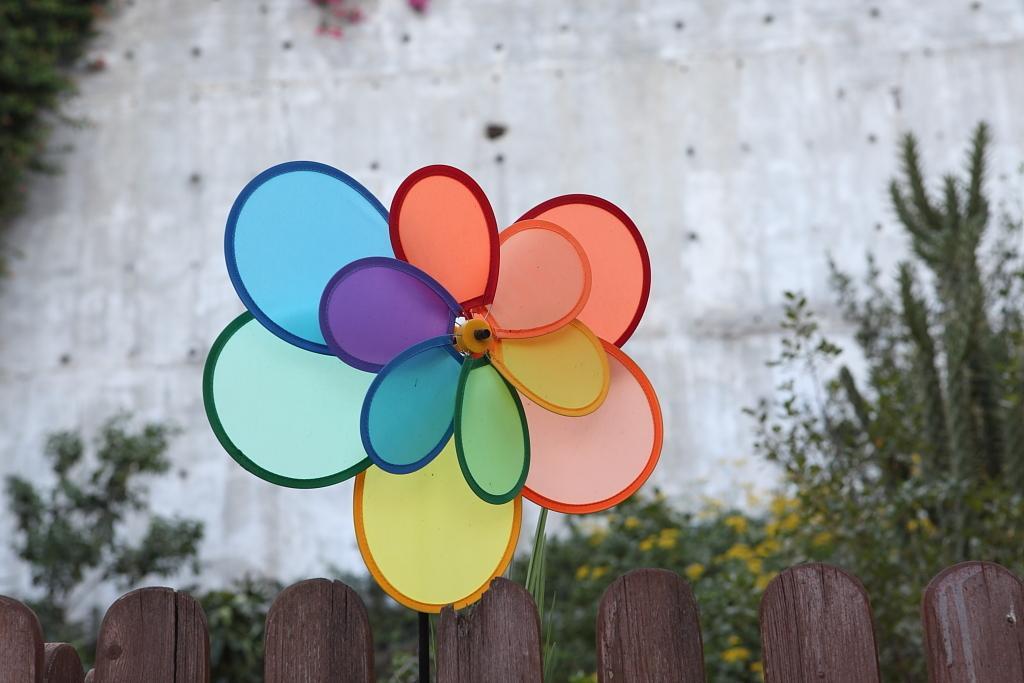Describe this image in one or two sentences. There is a decorative windmill on a wooden fencing. In the back there are plants. Also there is a wall. 